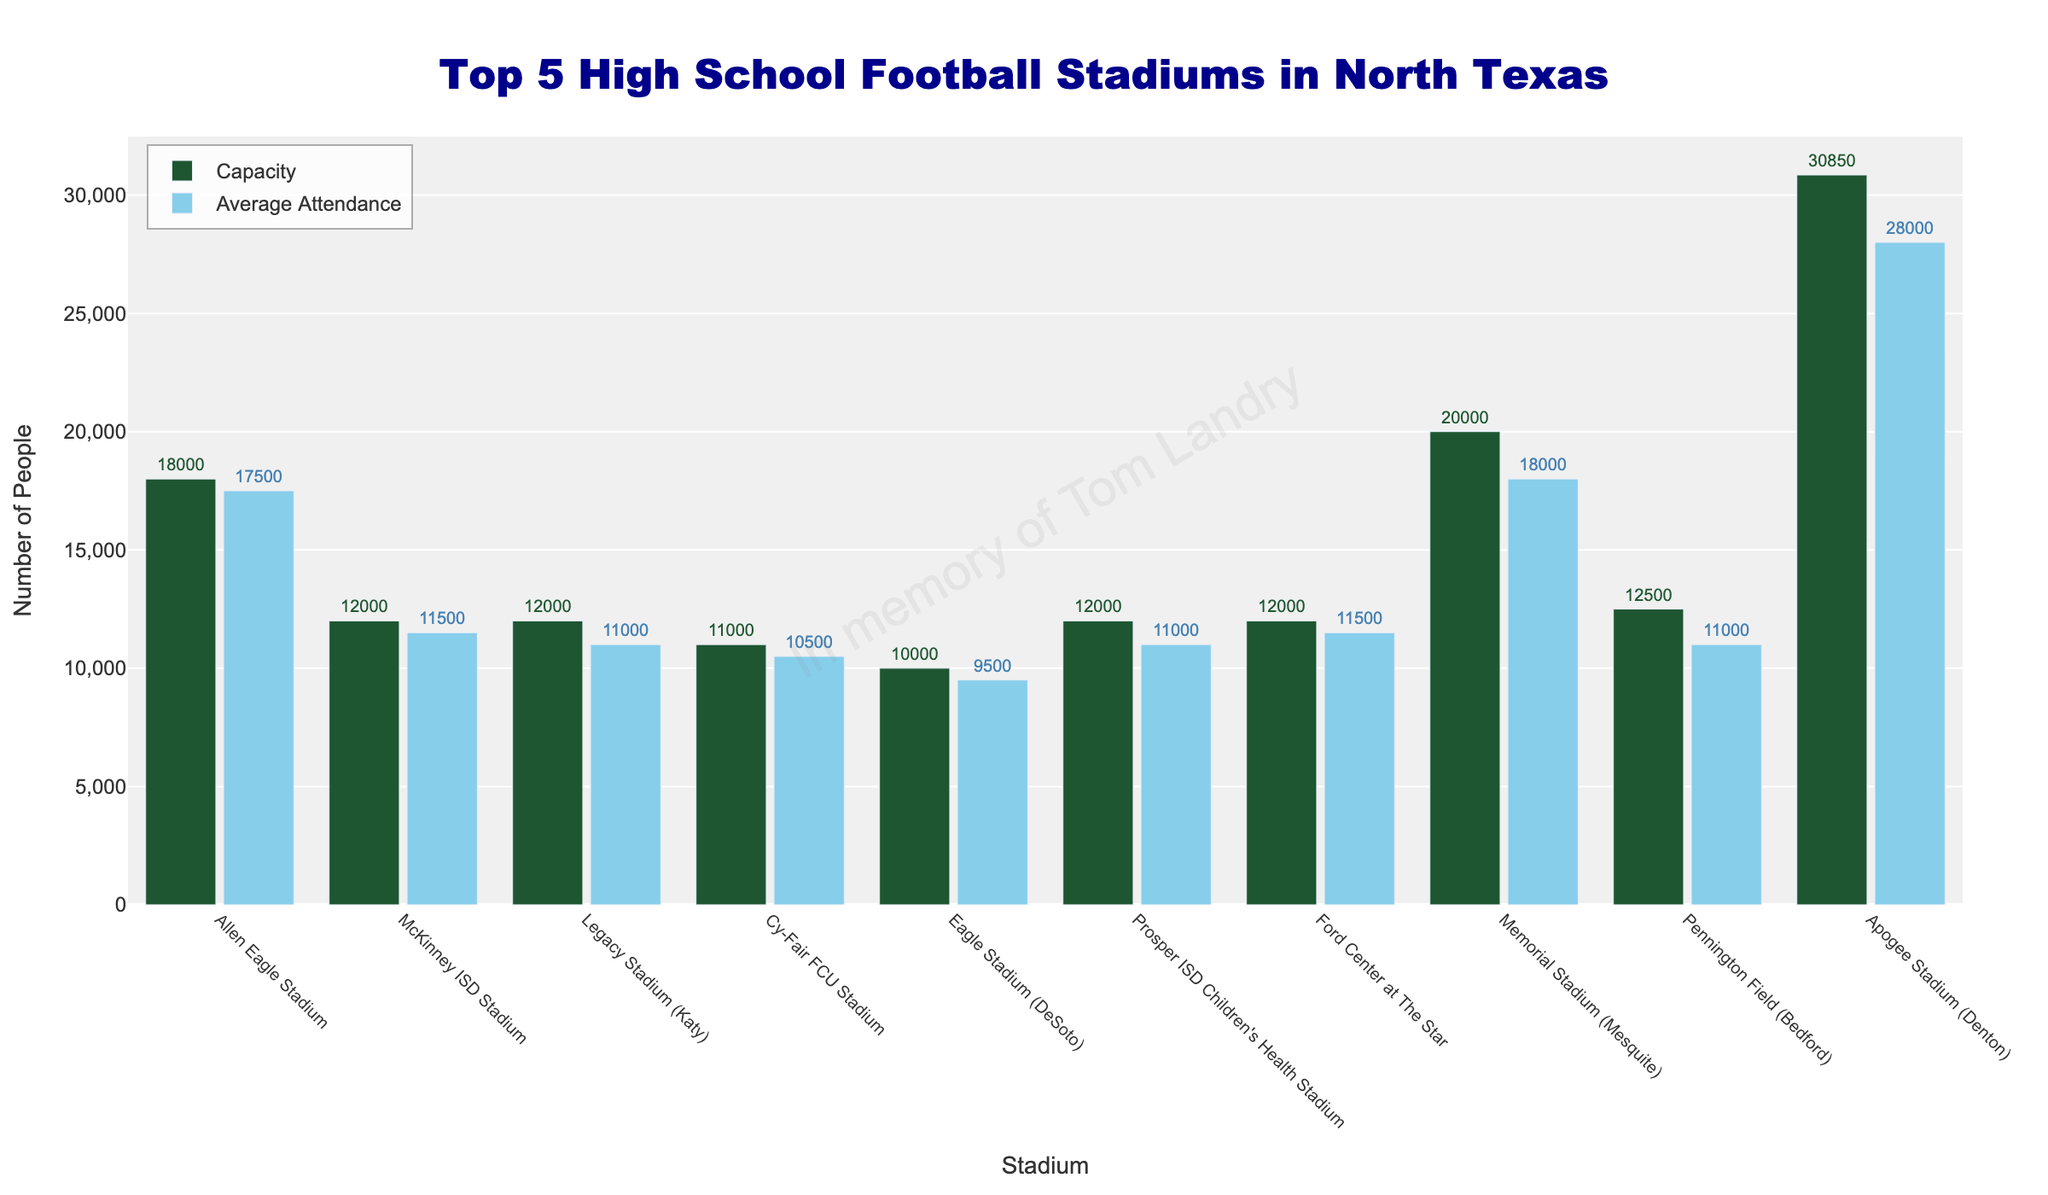Which stadium has the highest capacity? Memorial Stadium (Mesquite) has the highest capacity. This can be identified by looking for the tallest green bar in the chart representing the capacity values.
Answer: Memorial Stadium (Mesquite) Which stadium has the lowest average attendance? Eagle Stadium (DeSoto) has the lowest average attendance. This can be determined by looking for the shortest blue bar in the chart representing the average attendance values.
Answer: Eagle Stadium (DeSoto) What is the difference in capacity between Apogee Stadium (Denton) and Allen Eagle Stadium? Apogee Stadium (Denton) has a capacity of 30,850, while Allen Eagle Stadium has a capacity of 18,000. The difference is calculated as 30,850 - 18,000.
Answer: 12,850 Which stadiums have an average attendance of at least 11,500? By observing blue bars with average attendance values of 11,500 or more, we identify Allen Eagle Stadium (17,500), McKinney ISD Stadium (11,500), and Ford Center at The Star (11,500).
Answer: Allen Eagle Stadium, McKinney ISD Stadium, Ford Center at The Star What's the total average attendance across all the top 5 high school football stadiums? The average attendance for the top 5 stadiums are Allen Eagle Stadium: 17,500, McKinney ISD Stadium: 11,500, Legacy Stadium (Katy): 11,000, Cy-Fair FCU Stadium: 10,500, Eagle Stadium (DeSoto): 9,500. Sum these values to get the total.
Answer: 59,000 Among the top 5 stadiums, which one has the smallest difference between capacity and average attendance? Subtract the average attendance from the capacity for each stadium and look for the smallest result: (1) Allen Eagle Stadium: 500, (2) McKinney ISD Stadium: 500, (3) Legacy Stadium (Katy): 1,000, (4) Cy-Fair FCU Stadium: 500, (5) Eagle Stadium (DeSoto): 500.
Answer: Allen Eagle Stadium, McKinney ISD Stadium, Cy-Fair FCU Stadium, Eagle Stadium (DeSoto) Is there any stadium where the average attendance is equal to the capacity? Scan through the chart and verify if any blue bar aligns precisely with the top of a green bar. None of the stadiums have an average attendance that matches their capacity exactly.
Answer: No What is the ratio of capacity to average attendance for Allen Eagle Stadium? The capacity of Allen Eagle Stadium is 18,000, and its average attendance is 17,500. The ratio is calculated as 18,000 / 17,500.
Answer: 1.03 